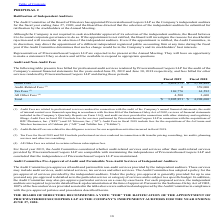According to Viavi Solutions's financial document, How much were Audit fees in 2019? According to the financial document, $3,631,575. The relevant text states: "Audit Fees (1) $ 3,631,575 $ 3,784,488..." Also, How much were Tax Fees in 2019? According to the financial document, 169,776. The relevant text states: "Tax Fees (3) 169,776 61,592..." Also, can you calculate: What is the change in Audit Fees as a percentage between 2018 and 2019? To answer this question, I need to perform calculations using the financial data. The calculation is: (3,631,575-3,784,488)/3,784,488, which equals -4.04 (percentage). This is based on the information: "Audit Fees (1) $ 3,631,575 $ 3,784,488 Audit Fees (1) $ 3,631,575 $ 3,784,488..." The key data points involved are: 3,631,575, 3,784,488. Also, can you calculate: What is the change in All Other Fees as a percentage between 2018 and 2019? To answer this question, I need to perform calculations using the financial data. The calculation is: (4,500-3,600)/3,600, which equals 25 (percentage). This is based on the information: "All Other Fees (4) 4,500 3,600 All Other Fees (4) 4,500 3,600..." The key data points involved are: 3,600, 4,500. Also, can you calculate: What is the total of Tax Fees and All Other Fees in 2019? Based on the calculation: 169,776+4,500, the result is 174276. This is based on the information: "All Other Fees (4) 4,500 3,600 Tax Fees (3) 169,776 61,592..." The key data points involved are: 169,776, 4,500. Also, What are Audit-Related fees related to? Audit-Related Fees are related to due diligence services for our acquisition activities incurred in fiscal 2018.. The document states: "(2) Audit-Related Fees are related to due diligence services for our acquisition activities incurred in fiscal 2018...." 